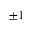Convert formula to latex. <formula><loc_0><loc_0><loc_500><loc_500>\pm 1</formula> 